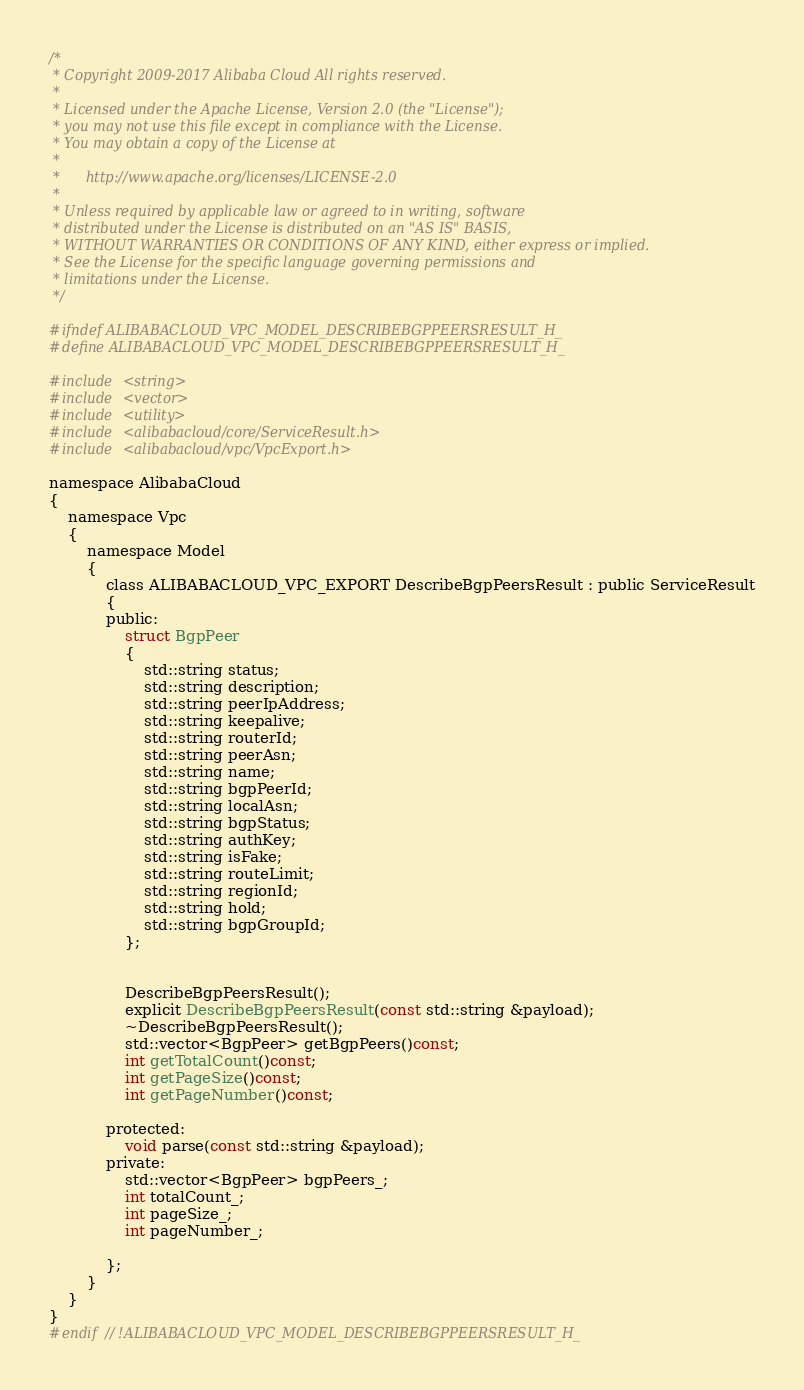<code> <loc_0><loc_0><loc_500><loc_500><_C_>/*
 * Copyright 2009-2017 Alibaba Cloud All rights reserved.
 * 
 * Licensed under the Apache License, Version 2.0 (the "License");
 * you may not use this file except in compliance with the License.
 * You may obtain a copy of the License at
 * 
 *      http://www.apache.org/licenses/LICENSE-2.0
 * 
 * Unless required by applicable law or agreed to in writing, software
 * distributed under the License is distributed on an "AS IS" BASIS,
 * WITHOUT WARRANTIES OR CONDITIONS OF ANY KIND, either express or implied.
 * See the License for the specific language governing permissions and
 * limitations under the License.
 */

#ifndef ALIBABACLOUD_VPC_MODEL_DESCRIBEBGPPEERSRESULT_H_
#define ALIBABACLOUD_VPC_MODEL_DESCRIBEBGPPEERSRESULT_H_

#include <string>
#include <vector>
#include <utility>
#include <alibabacloud/core/ServiceResult.h>
#include <alibabacloud/vpc/VpcExport.h>

namespace AlibabaCloud
{
	namespace Vpc
	{
		namespace Model
		{
			class ALIBABACLOUD_VPC_EXPORT DescribeBgpPeersResult : public ServiceResult
			{
			public:
				struct BgpPeer
				{
					std::string status;
					std::string description;
					std::string peerIpAddress;
					std::string keepalive;
					std::string routerId;
					std::string peerAsn;
					std::string name;
					std::string bgpPeerId;
					std::string localAsn;
					std::string bgpStatus;
					std::string authKey;
					std::string isFake;
					std::string routeLimit;
					std::string regionId;
					std::string hold;
					std::string bgpGroupId;
				};


				DescribeBgpPeersResult();
				explicit DescribeBgpPeersResult(const std::string &payload);
				~DescribeBgpPeersResult();
				std::vector<BgpPeer> getBgpPeers()const;
				int getTotalCount()const;
				int getPageSize()const;
				int getPageNumber()const;

			protected:
				void parse(const std::string &payload);
			private:
				std::vector<BgpPeer> bgpPeers_;
				int totalCount_;
				int pageSize_;
				int pageNumber_;

			};
		}
	}
}
#endif // !ALIBABACLOUD_VPC_MODEL_DESCRIBEBGPPEERSRESULT_H_</code> 